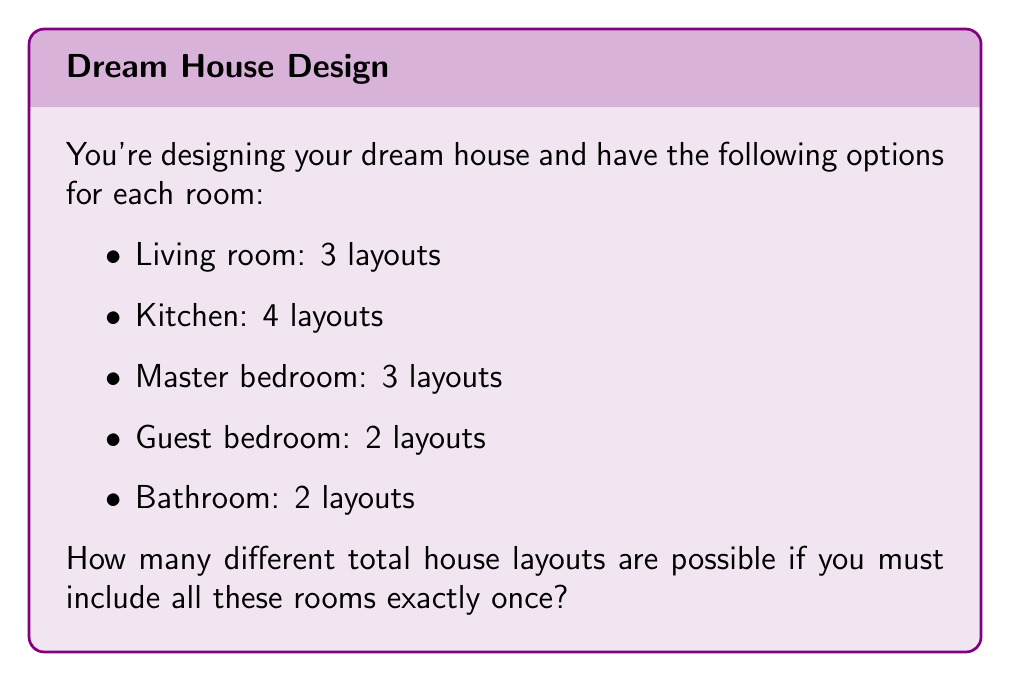Help me with this question. To solve this problem, we'll use the multiplication principle of counting. This principle states that if we have a sequence of independent choices, the total number of possible outcomes is the product of the number of options for each choice.

Let's break it down step-by-step:

1. Living room: 3 options
2. Kitchen: 4 options
3. Master bedroom: 3 options
4. Guest bedroom: 2 options
5. Bathroom: 2 options

For each room, we make an independent choice that doesn't affect the options for the other rooms. Therefore, we multiply the number of options for each room:

$$\text{Total layouts} = 3 \times 4 \times 3 \times 2 \times 2$$

Calculating this:
$$\text{Total layouts} = 3 \times 4 \times 3 \times 2 \times 2 = 144$$

Therefore, there are 144 possible different house layouts given these room options.
Answer: 144 